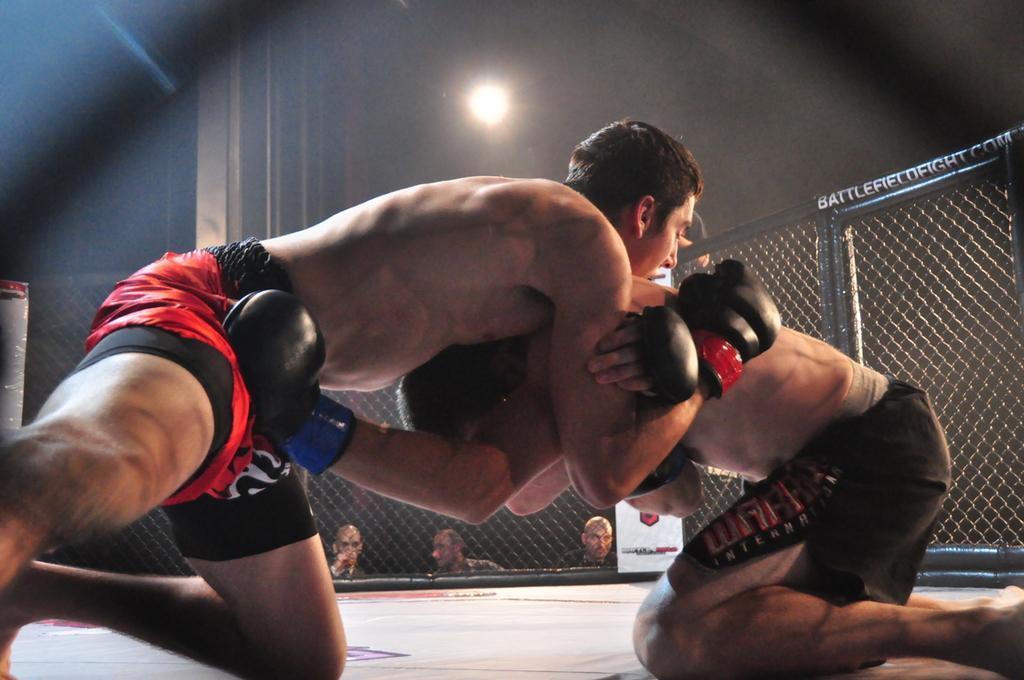Could you give a brief overview of what you see in this image? In this image we can see two people wrestling. In the background there is a net and we can see people. There is a board. At the top we can see a light. 